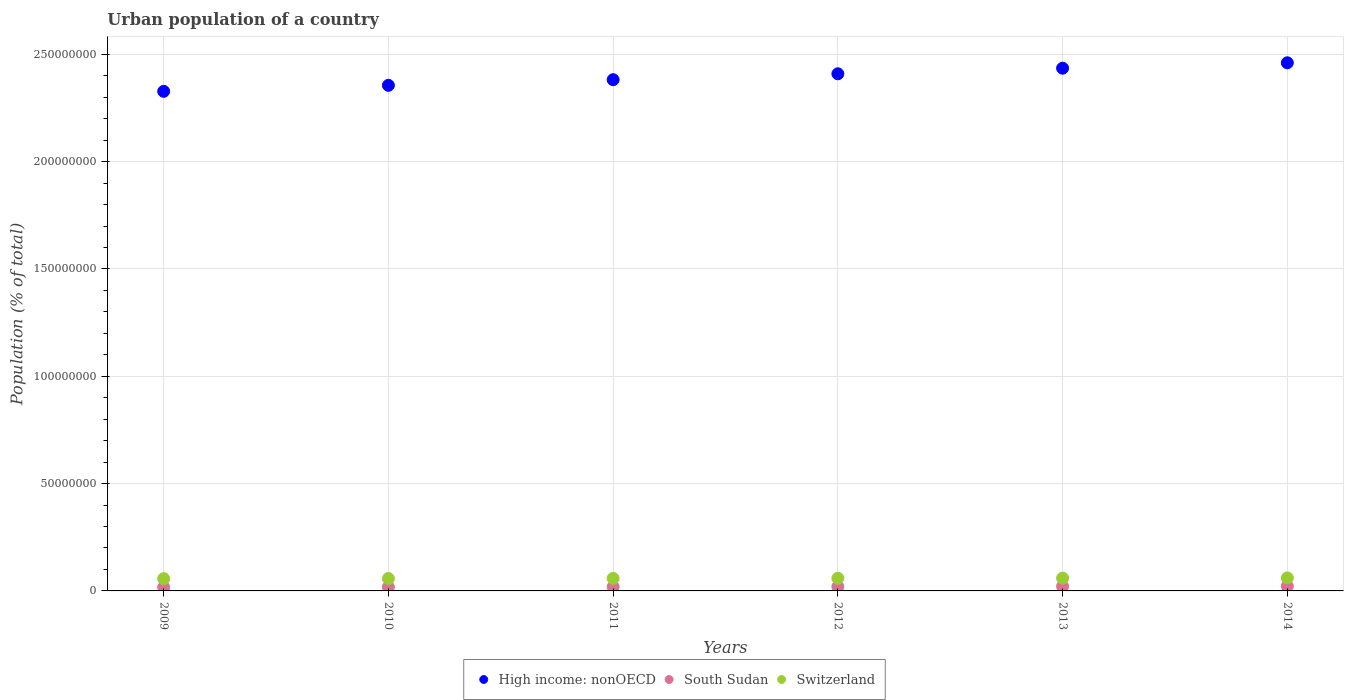What is the urban population in Switzerland in 2012?
Ensure brevity in your answer.  5.90e+06. Across all years, what is the maximum urban population in High income: nonOECD?
Your answer should be very brief. 2.46e+08. Across all years, what is the minimum urban population in South Sudan?
Your answer should be compact. 1.70e+06. In which year was the urban population in Switzerland maximum?
Offer a very short reply. 2014. In which year was the urban population in High income: nonOECD minimum?
Give a very brief answer. 2009. What is the total urban population in South Sudan in the graph?
Provide a succinct answer. 1.17e+07. What is the difference between the urban population in Switzerland in 2009 and that in 2010?
Make the answer very short. -6.27e+04. What is the difference between the urban population in High income: nonOECD in 2011 and the urban population in Switzerland in 2010?
Make the answer very short. 2.32e+08. What is the average urban population in Switzerland per year?
Your answer should be compact. 5.87e+06. In the year 2010, what is the difference between the urban population in South Sudan and urban population in Switzerland?
Your answer should be compact. -3.97e+06. In how many years, is the urban population in South Sudan greater than 110000000 %?
Your answer should be very brief. 0. What is the ratio of the urban population in High income: nonOECD in 2011 to that in 2012?
Your answer should be very brief. 0.99. What is the difference between the highest and the second highest urban population in Switzerland?
Offer a very short reply. 7.91e+04. What is the difference between the highest and the lowest urban population in High income: nonOECD?
Your answer should be compact. 1.33e+07. In how many years, is the urban population in High income: nonOECD greater than the average urban population in High income: nonOECD taken over all years?
Your answer should be compact. 3. How many dotlines are there?
Provide a succinct answer. 3. Does the graph contain any zero values?
Offer a terse response. No. Where does the legend appear in the graph?
Provide a short and direct response. Bottom center. How are the legend labels stacked?
Provide a succinct answer. Horizontal. What is the title of the graph?
Your response must be concise. Urban population of a country. What is the label or title of the X-axis?
Make the answer very short. Years. What is the label or title of the Y-axis?
Provide a short and direct response. Population (% of total). What is the Population (% of total) of High income: nonOECD in 2009?
Your answer should be very brief. 2.33e+08. What is the Population (% of total) in South Sudan in 2009?
Your answer should be very brief. 1.70e+06. What is the Population (% of total) of Switzerland in 2009?
Offer a terse response. 5.70e+06. What is the Population (% of total) of High income: nonOECD in 2010?
Offer a very short reply. 2.36e+08. What is the Population (% of total) of South Sudan in 2010?
Your response must be concise. 1.80e+06. What is the Population (% of total) of Switzerland in 2010?
Your answer should be very brief. 5.76e+06. What is the Population (% of total) of High income: nonOECD in 2011?
Keep it short and to the point. 2.38e+08. What is the Population (% of total) of South Sudan in 2011?
Your answer should be compact. 1.89e+06. What is the Population (% of total) in Switzerland in 2011?
Offer a very short reply. 5.83e+06. What is the Population (% of total) of High income: nonOECD in 2012?
Offer a very short reply. 2.41e+08. What is the Population (% of total) of South Sudan in 2012?
Give a very brief answer. 2.00e+06. What is the Population (% of total) of Switzerland in 2012?
Make the answer very short. 5.90e+06. What is the Population (% of total) in High income: nonOECD in 2013?
Offer a very short reply. 2.44e+08. What is the Population (% of total) of South Sudan in 2013?
Keep it short and to the point. 2.11e+06. What is the Population (% of total) of Switzerland in 2013?
Your answer should be compact. 5.97e+06. What is the Population (% of total) of High income: nonOECD in 2014?
Your response must be concise. 2.46e+08. What is the Population (% of total) in South Sudan in 2014?
Offer a very short reply. 2.21e+06. What is the Population (% of total) of Switzerland in 2014?
Ensure brevity in your answer.  6.05e+06. Across all years, what is the maximum Population (% of total) in High income: nonOECD?
Offer a terse response. 2.46e+08. Across all years, what is the maximum Population (% of total) in South Sudan?
Ensure brevity in your answer.  2.21e+06. Across all years, what is the maximum Population (% of total) in Switzerland?
Provide a short and direct response. 6.05e+06. Across all years, what is the minimum Population (% of total) in High income: nonOECD?
Provide a short and direct response. 2.33e+08. Across all years, what is the minimum Population (% of total) in South Sudan?
Make the answer very short. 1.70e+06. Across all years, what is the minimum Population (% of total) of Switzerland?
Your answer should be very brief. 5.70e+06. What is the total Population (% of total) in High income: nonOECD in the graph?
Your response must be concise. 1.44e+09. What is the total Population (% of total) of South Sudan in the graph?
Provide a succinct answer. 1.17e+07. What is the total Population (% of total) of Switzerland in the graph?
Make the answer very short. 3.52e+07. What is the difference between the Population (% of total) in High income: nonOECD in 2009 and that in 2010?
Keep it short and to the point. -2.81e+06. What is the difference between the Population (% of total) of South Sudan in 2009 and that in 2010?
Give a very brief answer. -9.24e+04. What is the difference between the Population (% of total) of Switzerland in 2009 and that in 2010?
Offer a very short reply. -6.27e+04. What is the difference between the Population (% of total) of High income: nonOECD in 2009 and that in 2011?
Ensure brevity in your answer.  -5.43e+06. What is the difference between the Population (% of total) in South Sudan in 2009 and that in 2011?
Offer a terse response. -1.91e+05. What is the difference between the Population (% of total) in Switzerland in 2009 and that in 2011?
Ensure brevity in your answer.  -1.30e+05. What is the difference between the Population (% of total) of High income: nonOECD in 2009 and that in 2012?
Provide a short and direct response. -8.18e+06. What is the difference between the Population (% of total) in South Sudan in 2009 and that in 2012?
Keep it short and to the point. -2.95e+05. What is the difference between the Population (% of total) of Switzerland in 2009 and that in 2012?
Your response must be concise. -1.95e+05. What is the difference between the Population (% of total) in High income: nonOECD in 2009 and that in 2013?
Make the answer very short. -1.08e+07. What is the difference between the Population (% of total) in South Sudan in 2009 and that in 2013?
Your answer should be very brief. -4.03e+05. What is the difference between the Population (% of total) of Switzerland in 2009 and that in 2013?
Keep it short and to the point. -2.67e+05. What is the difference between the Population (% of total) of High income: nonOECD in 2009 and that in 2014?
Your answer should be very brief. -1.33e+07. What is the difference between the Population (% of total) of South Sudan in 2009 and that in 2014?
Provide a succinct answer. -5.11e+05. What is the difference between the Population (% of total) of Switzerland in 2009 and that in 2014?
Ensure brevity in your answer.  -3.47e+05. What is the difference between the Population (% of total) of High income: nonOECD in 2010 and that in 2011?
Offer a very short reply. -2.62e+06. What is the difference between the Population (% of total) of South Sudan in 2010 and that in 2011?
Make the answer very short. -9.86e+04. What is the difference between the Population (% of total) of Switzerland in 2010 and that in 2011?
Give a very brief answer. -6.75e+04. What is the difference between the Population (% of total) of High income: nonOECD in 2010 and that in 2012?
Provide a short and direct response. -5.37e+06. What is the difference between the Population (% of total) in South Sudan in 2010 and that in 2012?
Ensure brevity in your answer.  -2.03e+05. What is the difference between the Population (% of total) in Switzerland in 2010 and that in 2012?
Ensure brevity in your answer.  -1.33e+05. What is the difference between the Population (% of total) in High income: nonOECD in 2010 and that in 2013?
Offer a terse response. -7.98e+06. What is the difference between the Population (% of total) in South Sudan in 2010 and that in 2013?
Offer a terse response. -3.11e+05. What is the difference between the Population (% of total) of Switzerland in 2010 and that in 2013?
Your answer should be compact. -2.05e+05. What is the difference between the Population (% of total) in High income: nonOECD in 2010 and that in 2014?
Your answer should be very brief. -1.05e+07. What is the difference between the Population (% of total) of South Sudan in 2010 and that in 2014?
Make the answer very short. -4.19e+05. What is the difference between the Population (% of total) in Switzerland in 2010 and that in 2014?
Offer a very short reply. -2.84e+05. What is the difference between the Population (% of total) of High income: nonOECD in 2011 and that in 2012?
Offer a very short reply. -2.75e+06. What is the difference between the Population (% of total) of South Sudan in 2011 and that in 2012?
Ensure brevity in your answer.  -1.04e+05. What is the difference between the Population (% of total) in Switzerland in 2011 and that in 2012?
Your answer should be compact. -6.53e+04. What is the difference between the Population (% of total) in High income: nonOECD in 2011 and that in 2013?
Your answer should be compact. -5.35e+06. What is the difference between the Population (% of total) in South Sudan in 2011 and that in 2013?
Make the answer very short. -2.12e+05. What is the difference between the Population (% of total) in Switzerland in 2011 and that in 2013?
Offer a very short reply. -1.37e+05. What is the difference between the Population (% of total) in High income: nonOECD in 2011 and that in 2014?
Your response must be concise. -7.87e+06. What is the difference between the Population (% of total) in South Sudan in 2011 and that in 2014?
Your response must be concise. -3.20e+05. What is the difference between the Population (% of total) in Switzerland in 2011 and that in 2014?
Ensure brevity in your answer.  -2.16e+05. What is the difference between the Population (% of total) of High income: nonOECD in 2012 and that in 2013?
Your answer should be very brief. -2.60e+06. What is the difference between the Population (% of total) in South Sudan in 2012 and that in 2013?
Offer a very short reply. -1.08e+05. What is the difference between the Population (% of total) of Switzerland in 2012 and that in 2013?
Your response must be concise. -7.21e+04. What is the difference between the Population (% of total) in High income: nonOECD in 2012 and that in 2014?
Provide a short and direct response. -5.12e+06. What is the difference between the Population (% of total) in South Sudan in 2012 and that in 2014?
Your answer should be compact. -2.16e+05. What is the difference between the Population (% of total) of Switzerland in 2012 and that in 2014?
Provide a succinct answer. -1.51e+05. What is the difference between the Population (% of total) of High income: nonOECD in 2013 and that in 2014?
Your answer should be compact. -2.52e+06. What is the difference between the Population (% of total) in South Sudan in 2013 and that in 2014?
Provide a short and direct response. -1.08e+05. What is the difference between the Population (% of total) of Switzerland in 2013 and that in 2014?
Keep it short and to the point. -7.91e+04. What is the difference between the Population (% of total) in High income: nonOECD in 2009 and the Population (% of total) in South Sudan in 2010?
Provide a short and direct response. 2.31e+08. What is the difference between the Population (% of total) of High income: nonOECD in 2009 and the Population (% of total) of Switzerland in 2010?
Make the answer very short. 2.27e+08. What is the difference between the Population (% of total) of South Sudan in 2009 and the Population (% of total) of Switzerland in 2010?
Keep it short and to the point. -4.06e+06. What is the difference between the Population (% of total) in High income: nonOECD in 2009 and the Population (% of total) in South Sudan in 2011?
Provide a short and direct response. 2.31e+08. What is the difference between the Population (% of total) of High income: nonOECD in 2009 and the Population (% of total) of Switzerland in 2011?
Offer a terse response. 2.27e+08. What is the difference between the Population (% of total) of South Sudan in 2009 and the Population (% of total) of Switzerland in 2011?
Make the answer very short. -4.13e+06. What is the difference between the Population (% of total) of High income: nonOECD in 2009 and the Population (% of total) of South Sudan in 2012?
Offer a very short reply. 2.31e+08. What is the difference between the Population (% of total) in High income: nonOECD in 2009 and the Population (% of total) in Switzerland in 2012?
Your response must be concise. 2.27e+08. What is the difference between the Population (% of total) of South Sudan in 2009 and the Population (% of total) of Switzerland in 2012?
Ensure brevity in your answer.  -4.19e+06. What is the difference between the Population (% of total) of High income: nonOECD in 2009 and the Population (% of total) of South Sudan in 2013?
Provide a short and direct response. 2.31e+08. What is the difference between the Population (% of total) of High income: nonOECD in 2009 and the Population (% of total) of Switzerland in 2013?
Offer a very short reply. 2.27e+08. What is the difference between the Population (% of total) in South Sudan in 2009 and the Population (% of total) in Switzerland in 2013?
Make the answer very short. -4.27e+06. What is the difference between the Population (% of total) in High income: nonOECD in 2009 and the Population (% of total) in South Sudan in 2014?
Make the answer very short. 2.31e+08. What is the difference between the Population (% of total) of High income: nonOECD in 2009 and the Population (% of total) of Switzerland in 2014?
Make the answer very short. 2.27e+08. What is the difference between the Population (% of total) in South Sudan in 2009 and the Population (% of total) in Switzerland in 2014?
Offer a terse response. -4.34e+06. What is the difference between the Population (% of total) in High income: nonOECD in 2010 and the Population (% of total) in South Sudan in 2011?
Offer a very short reply. 2.34e+08. What is the difference between the Population (% of total) of High income: nonOECD in 2010 and the Population (% of total) of Switzerland in 2011?
Your answer should be compact. 2.30e+08. What is the difference between the Population (% of total) in South Sudan in 2010 and the Population (% of total) in Switzerland in 2011?
Provide a short and direct response. -4.04e+06. What is the difference between the Population (% of total) in High income: nonOECD in 2010 and the Population (% of total) in South Sudan in 2012?
Ensure brevity in your answer.  2.34e+08. What is the difference between the Population (% of total) of High income: nonOECD in 2010 and the Population (% of total) of Switzerland in 2012?
Keep it short and to the point. 2.30e+08. What is the difference between the Population (% of total) of South Sudan in 2010 and the Population (% of total) of Switzerland in 2012?
Offer a terse response. -4.10e+06. What is the difference between the Population (% of total) in High income: nonOECD in 2010 and the Population (% of total) in South Sudan in 2013?
Offer a very short reply. 2.33e+08. What is the difference between the Population (% of total) in High income: nonOECD in 2010 and the Population (% of total) in Switzerland in 2013?
Your answer should be compact. 2.30e+08. What is the difference between the Population (% of total) of South Sudan in 2010 and the Population (% of total) of Switzerland in 2013?
Give a very brief answer. -4.17e+06. What is the difference between the Population (% of total) in High income: nonOECD in 2010 and the Population (% of total) in South Sudan in 2014?
Your response must be concise. 2.33e+08. What is the difference between the Population (% of total) in High income: nonOECD in 2010 and the Population (% of total) in Switzerland in 2014?
Keep it short and to the point. 2.30e+08. What is the difference between the Population (% of total) in South Sudan in 2010 and the Population (% of total) in Switzerland in 2014?
Keep it short and to the point. -4.25e+06. What is the difference between the Population (% of total) of High income: nonOECD in 2011 and the Population (% of total) of South Sudan in 2012?
Offer a very short reply. 2.36e+08. What is the difference between the Population (% of total) in High income: nonOECD in 2011 and the Population (% of total) in Switzerland in 2012?
Give a very brief answer. 2.32e+08. What is the difference between the Population (% of total) of South Sudan in 2011 and the Population (% of total) of Switzerland in 2012?
Provide a short and direct response. -4.00e+06. What is the difference between the Population (% of total) of High income: nonOECD in 2011 and the Population (% of total) of South Sudan in 2013?
Provide a succinct answer. 2.36e+08. What is the difference between the Population (% of total) in High income: nonOECD in 2011 and the Population (% of total) in Switzerland in 2013?
Provide a short and direct response. 2.32e+08. What is the difference between the Population (% of total) of South Sudan in 2011 and the Population (% of total) of Switzerland in 2013?
Offer a very short reply. -4.07e+06. What is the difference between the Population (% of total) in High income: nonOECD in 2011 and the Population (% of total) in South Sudan in 2014?
Give a very brief answer. 2.36e+08. What is the difference between the Population (% of total) of High income: nonOECD in 2011 and the Population (% of total) of Switzerland in 2014?
Offer a terse response. 2.32e+08. What is the difference between the Population (% of total) in South Sudan in 2011 and the Population (% of total) in Switzerland in 2014?
Keep it short and to the point. -4.15e+06. What is the difference between the Population (% of total) in High income: nonOECD in 2012 and the Population (% of total) in South Sudan in 2013?
Keep it short and to the point. 2.39e+08. What is the difference between the Population (% of total) of High income: nonOECD in 2012 and the Population (% of total) of Switzerland in 2013?
Provide a succinct answer. 2.35e+08. What is the difference between the Population (% of total) in South Sudan in 2012 and the Population (% of total) in Switzerland in 2013?
Make the answer very short. -3.97e+06. What is the difference between the Population (% of total) in High income: nonOECD in 2012 and the Population (% of total) in South Sudan in 2014?
Your answer should be very brief. 2.39e+08. What is the difference between the Population (% of total) of High income: nonOECD in 2012 and the Population (% of total) of Switzerland in 2014?
Make the answer very short. 2.35e+08. What is the difference between the Population (% of total) in South Sudan in 2012 and the Population (% of total) in Switzerland in 2014?
Provide a short and direct response. -4.05e+06. What is the difference between the Population (% of total) in High income: nonOECD in 2013 and the Population (% of total) in South Sudan in 2014?
Your response must be concise. 2.41e+08. What is the difference between the Population (% of total) in High income: nonOECD in 2013 and the Population (% of total) in Switzerland in 2014?
Give a very brief answer. 2.38e+08. What is the difference between the Population (% of total) in South Sudan in 2013 and the Population (% of total) in Switzerland in 2014?
Your response must be concise. -3.94e+06. What is the average Population (% of total) in High income: nonOECD per year?
Provide a succinct answer. 2.40e+08. What is the average Population (% of total) of South Sudan per year?
Your answer should be very brief. 1.95e+06. What is the average Population (% of total) of Switzerland per year?
Your response must be concise. 5.87e+06. In the year 2009, what is the difference between the Population (% of total) of High income: nonOECD and Population (% of total) of South Sudan?
Provide a short and direct response. 2.31e+08. In the year 2009, what is the difference between the Population (% of total) in High income: nonOECD and Population (% of total) in Switzerland?
Your response must be concise. 2.27e+08. In the year 2009, what is the difference between the Population (% of total) of South Sudan and Population (% of total) of Switzerland?
Provide a succinct answer. -4.00e+06. In the year 2010, what is the difference between the Population (% of total) in High income: nonOECD and Population (% of total) in South Sudan?
Your response must be concise. 2.34e+08. In the year 2010, what is the difference between the Population (% of total) in High income: nonOECD and Population (% of total) in Switzerland?
Provide a short and direct response. 2.30e+08. In the year 2010, what is the difference between the Population (% of total) in South Sudan and Population (% of total) in Switzerland?
Your answer should be very brief. -3.97e+06. In the year 2011, what is the difference between the Population (% of total) in High income: nonOECD and Population (% of total) in South Sudan?
Offer a terse response. 2.36e+08. In the year 2011, what is the difference between the Population (% of total) of High income: nonOECD and Population (% of total) of Switzerland?
Give a very brief answer. 2.32e+08. In the year 2011, what is the difference between the Population (% of total) in South Sudan and Population (% of total) in Switzerland?
Offer a very short reply. -3.94e+06. In the year 2012, what is the difference between the Population (% of total) of High income: nonOECD and Population (% of total) of South Sudan?
Offer a terse response. 2.39e+08. In the year 2012, what is the difference between the Population (% of total) of High income: nonOECD and Population (% of total) of Switzerland?
Give a very brief answer. 2.35e+08. In the year 2012, what is the difference between the Population (% of total) of South Sudan and Population (% of total) of Switzerland?
Your answer should be very brief. -3.90e+06. In the year 2013, what is the difference between the Population (% of total) of High income: nonOECD and Population (% of total) of South Sudan?
Give a very brief answer. 2.41e+08. In the year 2013, what is the difference between the Population (% of total) of High income: nonOECD and Population (% of total) of Switzerland?
Your response must be concise. 2.38e+08. In the year 2013, what is the difference between the Population (% of total) in South Sudan and Population (% of total) in Switzerland?
Make the answer very short. -3.86e+06. In the year 2014, what is the difference between the Population (% of total) of High income: nonOECD and Population (% of total) of South Sudan?
Your answer should be very brief. 2.44e+08. In the year 2014, what is the difference between the Population (% of total) of High income: nonOECD and Population (% of total) of Switzerland?
Provide a succinct answer. 2.40e+08. In the year 2014, what is the difference between the Population (% of total) in South Sudan and Population (% of total) in Switzerland?
Provide a short and direct response. -3.83e+06. What is the ratio of the Population (% of total) in South Sudan in 2009 to that in 2010?
Keep it short and to the point. 0.95. What is the ratio of the Population (% of total) in High income: nonOECD in 2009 to that in 2011?
Provide a succinct answer. 0.98. What is the ratio of the Population (% of total) in South Sudan in 2009 to that in 2011?
Keep it short and to the point. 0.9. What is the ratio of the Population (% of total) of Switzerland in 2009 to that in 2011?
Your response must be concise. 0.98. What is the ratio of the Population (% of total) of South Sudan in 2009 to that in 2012?
Your answer should be compact. 0.85. What is the ratio of the Population (% of total) of Switzerland in 2009 to that in 2012?
Make the answer very short. 0.97. What is the ratio of the Population (% of total) in High income: nonOECD in 2009 to that in 2013?
Your answer should be compact. 0.96. What is the ratio of the Population (% of total) of South Sudan in 2009 to that in 2013?
Keep it short and to the point. 0.81. What is the ratio of the Population (% of total) in Switzerland in 2009 to that in 2013?
Your response must be concise. 0.96. What is the ratio of the Population (% of total) in High income: nonOECD in 2009 to that in 2014?
Your answer should be very brief. 0.95. What is the ratio of the Population (% of total) of South Sudan in 2009 to that in 2014?
Give a very brief answer. 0.77. What is the ratio of the Population (% of total) of Switzerland in 2009 to that in 2014?
Your answer should be compact. 0.94. What is the ratio of the Population (% of total) of South Sudan in 2010 to that in 2011?
Keep it short and to the point. 0.95. What is the ratio of the Population (% of total) in Switzerland in 2010 to that in 2011?
Provide a short and direct response. 0.99. What is the ratio of the Population (% of total) in High income: nonOECD in 2010 to that in 2012?
Give a very brief answer. 0.98. What is the ratio of the Population (% of total) in South Sudan in 2010 to that in 2012?
Offer a terse response. 0.9. What is the ratio of the Population (% of total) of Switzerland in 2010 to that in 2012?
Give a very brief answer. 0.98. What is the ratio of the Population (% of total) in High income: nonOECD in 2010 to that in 2013?
Your answer should be very brief. 0.97. What is the ratio of the Population (% of total) in South Sudan in 2010 to that in 2013?
Give a very brief answer. 0.85. What is the ratio of the Population (% of total) in Switzerland in 2010 to that in 2013?
Provide a short and direct response. 0.97. What is the ratio of the Population (% of total) in High income: nonOECD in 2010 to that in 2014?
Your answer should be very brief. 0.96. What is the ratio of the Population (% of total) in South Sudan in 2010 to that in 2014?
Keep it short and to the point. 0.81. What is the ratio of the Population (% of total) in Switzerland in 2010 to that in 2014?
Give a very brief answer. 0.95. What is the ratio of the Population (% of total) in High income: nonOECD in 2011 to that in 2012?
Your response must be concise. 0.99. What is the ratio of the Population (% of total) of South Sudan in 2011 to that in 2012?
Keep it short and to the point. 0.95. What is the ratio of the Population (% of total) of Switzerland in 2011 to that in 2012?
Ensure brevity in your answer.  0.99. What is the ratio of the Population (% of total) of South Sudan in 2011 to that in 2013?
Offer a terse response. 0.9. What is the ratio of the Population (% of total) of High income: nonOECD in 2011 to that in 2014?
Offer a very short reply. 0.97. What is the ratio of the Population (% of total) in South Sudan in 2011 to that in 2014?
Your response must be concise. 0.86. What is the ratio of the Population (% of total) of Switzerland in 2011 to that in 2014?
Your answer should be very brief. 0.96. What is the ratio of the Population (% of total) of High income: nonOECD in 2012 to that in 2013?
Your answer should be compact. 0.99. What is the ratio of the Population (% of total) of South Sudan in 2012 to that in 2013?
Provide a succinct answer. 0.95. What is the ratio of the Population (% of total) of Switzerland in 2012 to that in 2013?
Provide a short and direct response. 0.99. What is the ratio of the Population (% of total) in High income: nonOECD in 2012 to that in 2014?
Your answer should be very brief. 0.98. What is the ratio of the Population (% of total) of South Sudan in 2012 to that in 2014?
Your answer should be compact. 0.9. What is the ratio of the Population (% of total) of High income: nonOECD in 2013 to that in 2014?
Provide a succinct answer. 0.99. What is the ratio of the Population (% of total) in South Sudan in 2013 to that in 2014?
Your answer should be compact. 0.95. What is the ratio of the Population (% of total) of Switzerland in 2013 to that in 2014?
Your answer should be compact. 0.99. What is the difference between the highest and the second highest Population (% of total) of High income: nonOECD?
Make the answer very short. 2.52e+06. What is the difference between the highest and the second highest Population (% of total) in South Sudan?
Your answer should be compact. 1.08e+05. What is the difference between the highest and the second highest Population (% of total) in Switzerland?
Offer a terse response. 7.91e+04. What is the difference between the highest and the lowest Population (% of total) in High income: nonOECD?
Offer a terse response. 1.33e+07. What is the difference between the highest and the lowest Population (% of total) of South Sudan?
Give a very brief answer. 5.11e+05. What is the difference between the highest and the lowest Population (% of total) in Switzerland?
Your response must be concise. 3.47e+05. 